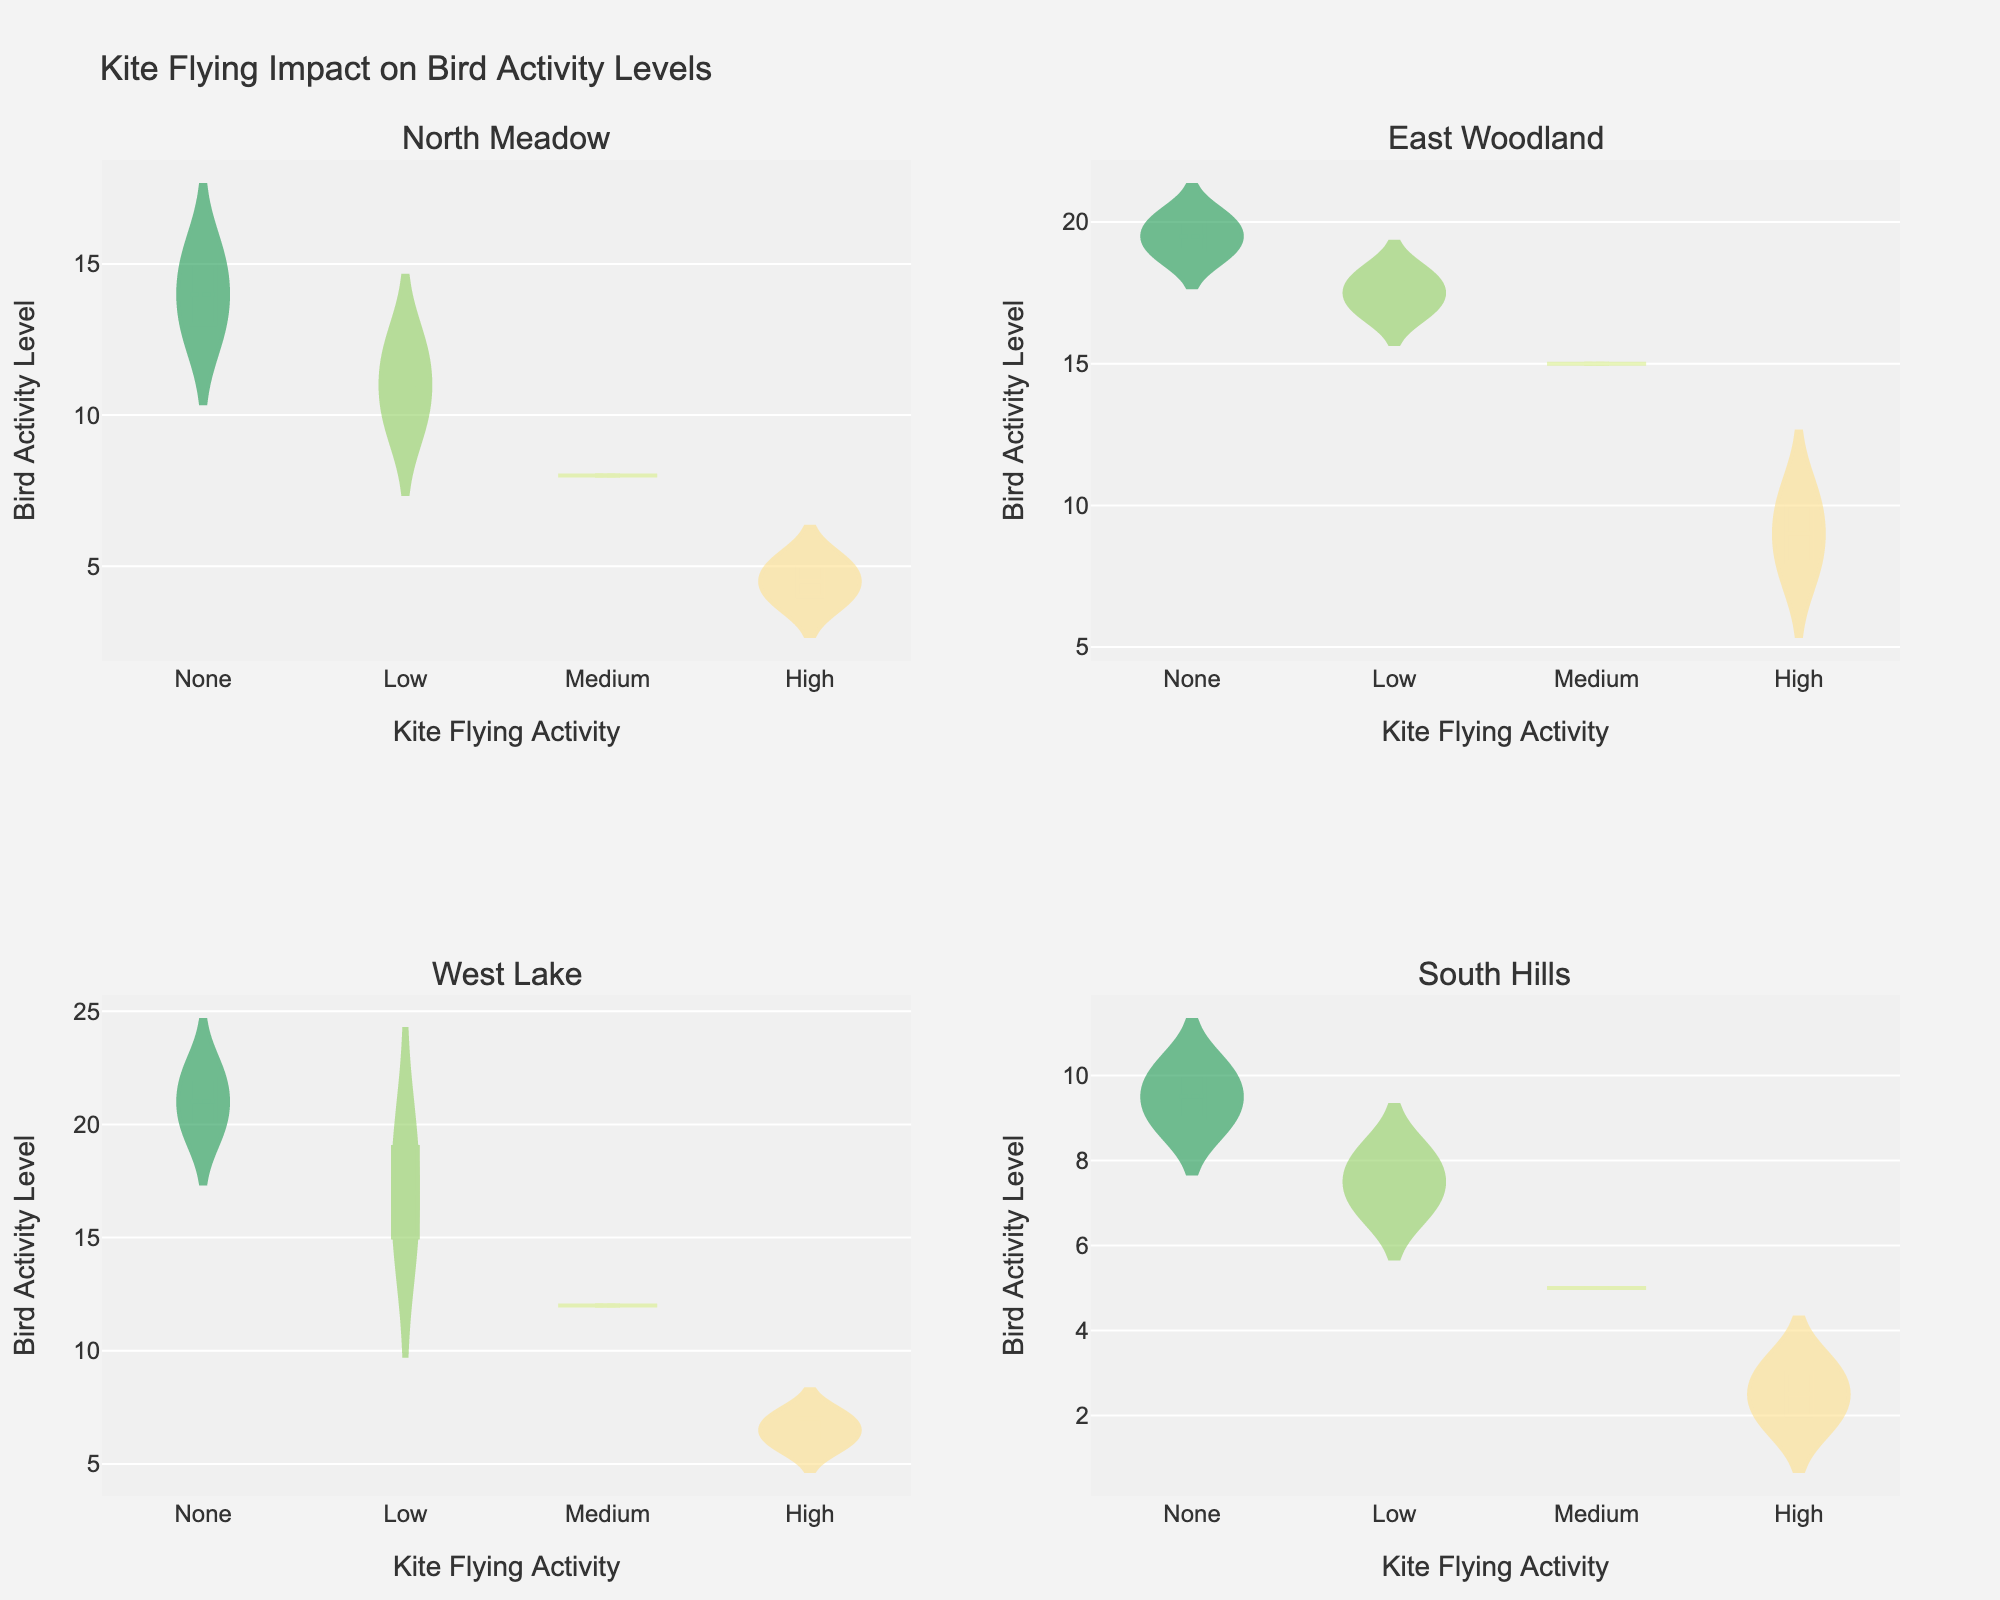How does kite flying activity impact bird activity levels in North Meadow? To compare the bird activity levels at different kite flying activities in North Meadow, we examine the densities of each activity level. As the kite flying activity increases from 'None' to 'High', the bird activity level generally decreases.
Answer: Bird activity levels decrease with increasing kite flying activity Which bird species experienced the lowest impact on activity level with low kite flying activity? We need to compare the bird activity levels under 'Low' kite flying activity for all bird species. Sparrows and Blue Jays both have moderately high activity levels under 'Low' kite flying activity, but Ducks have noticeably higher bird activity levels.
Answer: Ducks What is the general trend of bird activity levels in West Lake as kite flying activity increases? By observing the West Lake subplot, we see that the bird activity level trend decreases as the kite flying activity progresses from 'None' to 'High'.
Answer: The bird activity levels decrease During which time period do we see the lowest bird activity in South Hills when kite flying activity is none? By examining the South Hills subplot under 'None' kite flying activity, we see that the bird activity levels are generally low at 06:00 and 18:00. The lowest observed is at 06:00 with a bird activity level of 10.
Answer: 06:00 Comparing 'Low' and 'High' kite flying activities, which location shows the greatest difference in bird activity levels? We need to find the difference in bird activity levels between 'Low' and 'High' kite flying activities for each location. The North Meadow and South Hills show large differences, but North Meadow has the greatest difference.
Answer: North Meadow Which location maintains the highest bird activity level generally when kite flying is absent? By looking at the subplots for each location under 'None', West Lake has consistently higher bird activity levels compared to other locations.
Answer: West Lake In East Woodland at midday (12:00), what is the bird activity level when kite flying is high? The East Woodland subplot shows 'High' kite flying activity around the midday mark and indicates that the bird activity level is about 10 at this time.
Answer: 10 What is the variation in bird activity levels for Blue Jays in East Woodland with no kite flying activity? To assess the variation, we examine the East Woodland subplot under 'None' kite flying activity for Blue Jays. The bird activity levels range from around 18 to 20.
Answer: 18 to 20 How do activity levels of Hawks in South Hills compare to Ducks in West Lake as kite flying activity increases from None to High? Comparing the 'None', 'Low', 'Medium', and 'High' subplots for both species, we observe that Hawks in South Hills experience a sharper decline in activity levels compared to Ducks in West Lake as kite flying increases.
Answer: Hawks decline more sharply What is the median bird activity level for Sparrows in North Meadow when kite flying activity is 'Medium'? The median can be seen in the North Meadow plot under 'Medium' kite flying activity as halfway-between the data points which places it around 8.
Answer: 8 